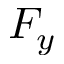<formula> <loc_0><loc_0><loc_500><loc_500>F _ { y }</formula> 